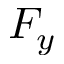<formula> <loc_0><loc_0><loc_500><loc_500>F _ { y }</formula> 